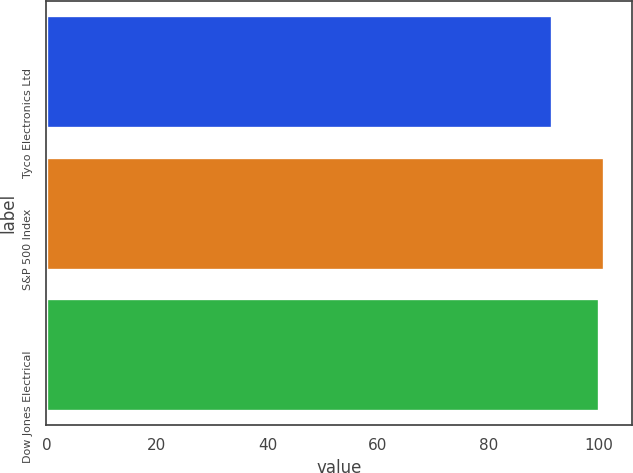Convert chart. <chart><loc_0><loc_0><loc_500><loc_500><bar_chart><fcel>Tyco Electronics Ltd<fcel>S&P 500 Index<fcel>Dow Jones Electrical<nl><fcel>91.56<fcel>100.89<fcel>99.97<nl></chart> 